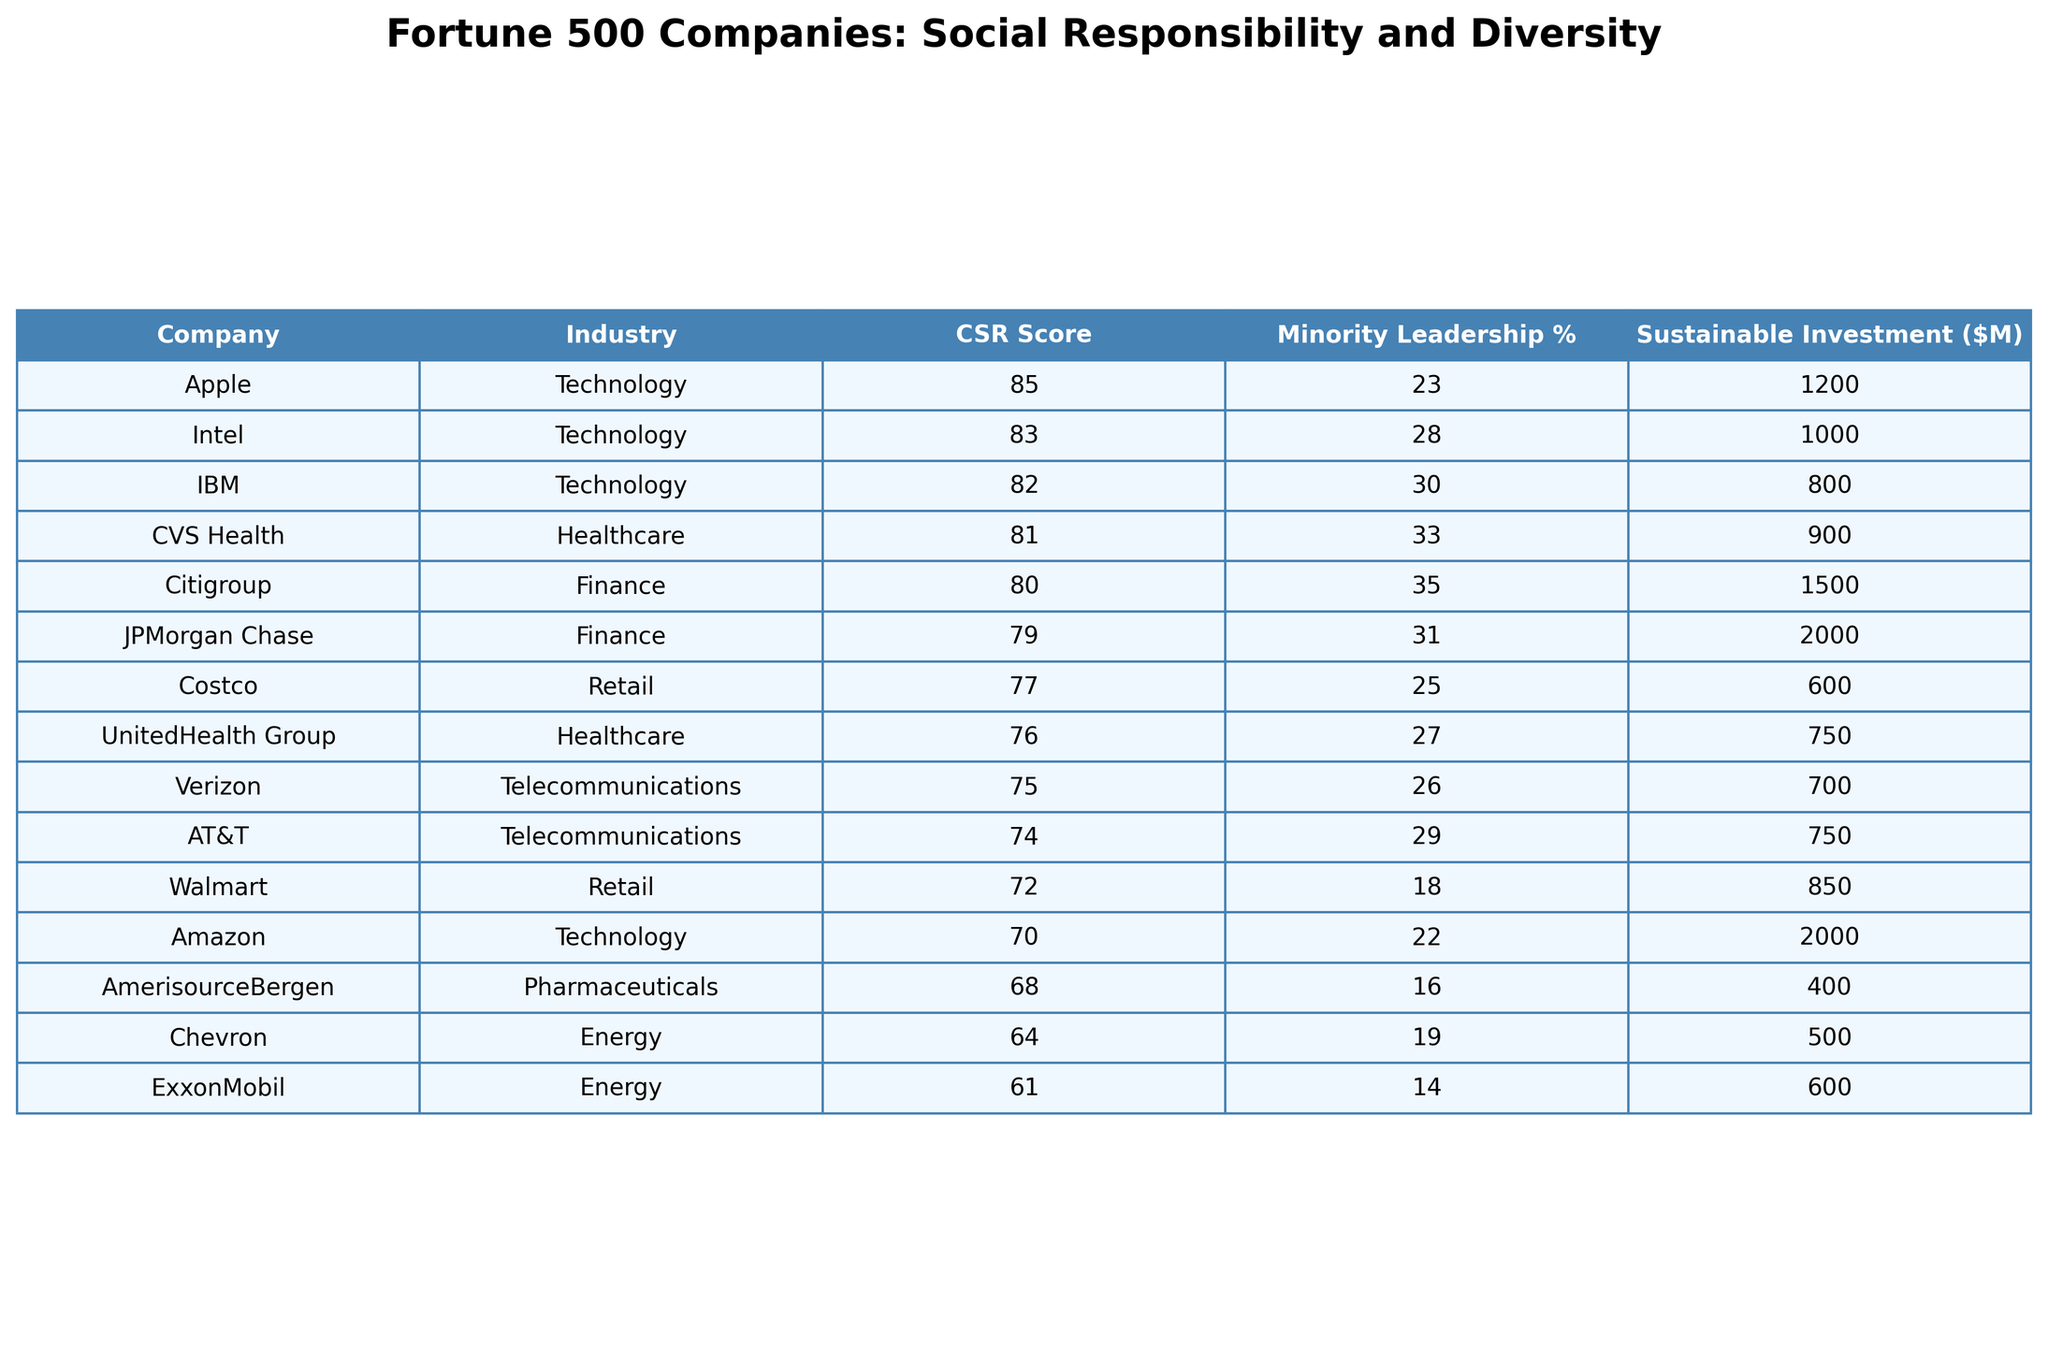What is the highest Social Responsibility Score among the listed companies? Looking at the Social Responsibility Score column, Apple has the highest score at 85.
Answer: 85 Which company has the lowest Sustainable Investment Amount? By checking the Sustainable Investment Amount ($M) column, AmerisourceBergen has the lowest amount at 400 million dollars.
Answer: 400 How many companies have a Minority Leadership Percentage of 30% or above? Inspecting the Minority Leadership Percentage column, there are three companies: JPMorgan Chase, CVS Health, and Citigroup.
Answer: 3 What is the average Social Responsibility Score of companies in the healthcare industry? Calculating the average from the scores of UnitedHealth Group (76), CVS Health (81), and AmerisourceBergen (68): (76 + 81 + 68) / 3 = 75.
Answer: 75 Is ExxonMobil the only company with a Social Responsibility Score below 65? Referring to the Social Responsibility Score column, there are two companies, ExxonMobil (61) and Chevron (64), that have scores below 65. Therefore, the statement is false.
Answer: No What is the total Sustainable Investment Amount from the top three companies based on Social Responsibility Score? The top three companies are Apple (1200), Intel (1000), and JPMorgan Chase (2000). The total is 1200 + 1000 + 2000 = 4200 million dollars.
Answer: 4200 Which industry does the company with the highest Social Responsibility Score belong to? Since Apple has the highest score at 85, and it belongs to the Technology industry, the answer is Technology.
Answer: Technology Are there any companies in the Retail industry with a Social Responsibility Score above 75? Checking the scores for Costco (77) and Walmart (72), Costco is the only company in the Retail industry above 75. So, the answer is yes.
Answer: Yes What percentage of minority leadership does Amazon have? Referring to the Minority Leadership Percentage column, Amazon has a percentage of 22.
Answer: 22 What is the difference in Social Responsibility Scores between the highest and lowest scoring companies? The highest score is from Apple (85) and the lowest is from ExxonMobil (61). The difference is 85 - 61 = 24.
Answer: 24 